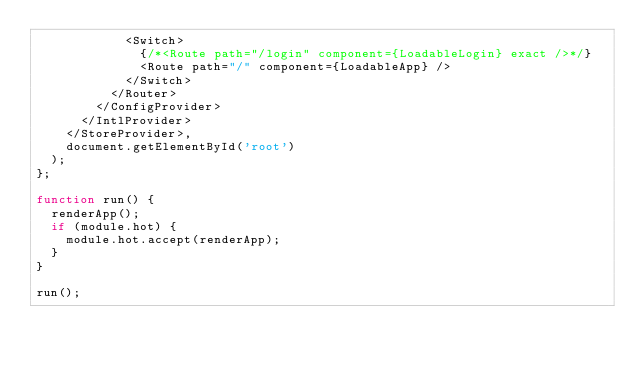Convert code to text. <code><loc_0><loc_0><loc_500><loc_500><_JavaScript_>            <Switch>
              {/*<Route path="/login" component={LoadableLogin} exact />*/}
              <Route path="/" component={LoadableApp} />
            </Switch>
          </Router>
        </ConfigProvider>
      </IntlProvider>
    </StoreProvider>,
    document.getElementById('root')
  );
};

function run() {
  renderApp();
  if (module.hot) {
    module.hot.accept(renderApp);
  }
}

run();
</code> 